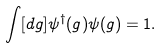<formula> <loc_0><loc_0><loc_500><loc_500>\int [ d g ] \psi ^ { \dagger } ( g ) \psi ( g ) = 1 .</formula> 